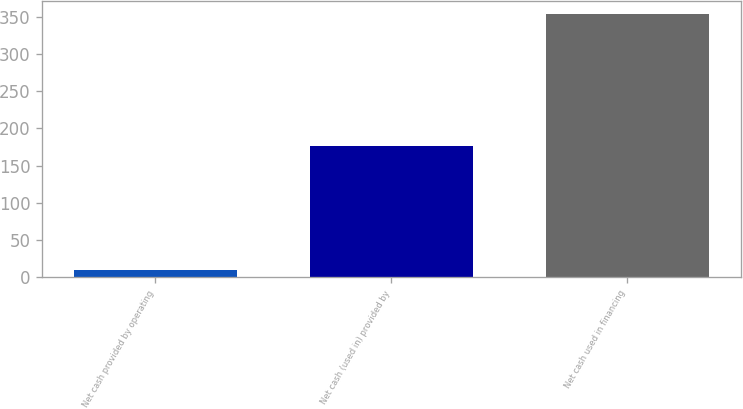Convert chart to OTSL. <chart><loc_0><loc_0><loc_500><loc_500><bar_chart><fcel>Net cash provided by operating<fcel>Net cash (used in) provided by<fcel>Net cash used in financing<nl><fcel>10<fcel>177<fcel>354<nl></chart> 